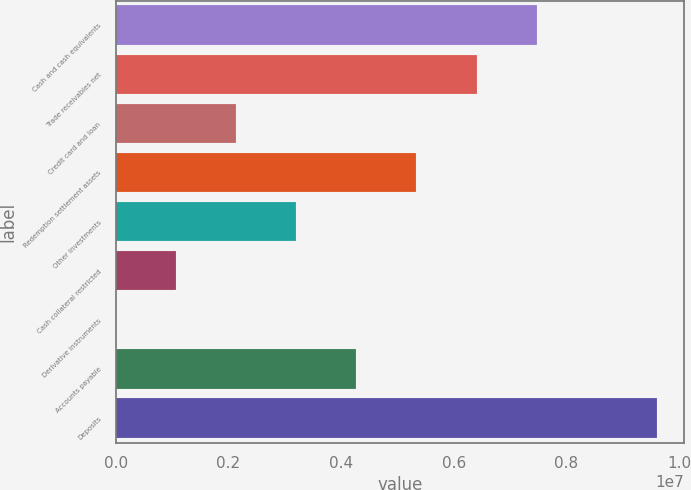Convert chart. <chart><loc_0><loc_0><loc_500><loc_500><bar_chart><fcel>Cash and cash equivalents<fcel>Trade receivables net<fcel>Credit card and loan<fcel>Redemption settlement assets<fcel>Other investments<fcel>Cash collateral restricted<fcel>Derivative instruments<fcel>Accounts payable<fcel>Deposits<nl><fcel>7.47276e+06<fcel>6.40577e+06<fcel>2.13784e+06<fcel>5.33879e+06<fcel>3.20482e+06<fcel>1.07085e+06<fcel>3871<fcel>4.27181e+06<fcel>9.60673e+06<nl></chart> 